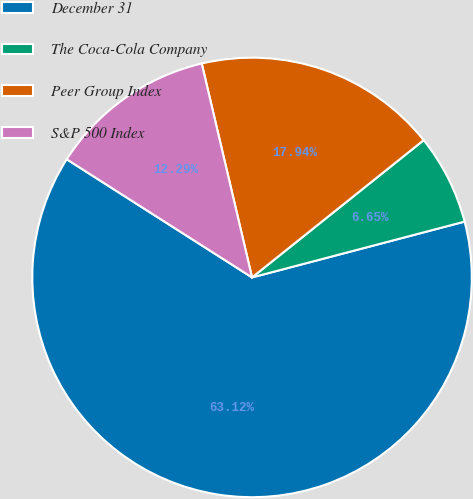<chart> <loc_0><loc_0><loc_500><loc_500><pie_chart><fcel>December 31<fcel>The Coca-Cola Company<fcel>Peer Group Index<fcel>S&P 500 Index<nl><fcel>63.12%<fcel>6.65%<fcel>17.94%<fcel>12.29%<nl></chart> 